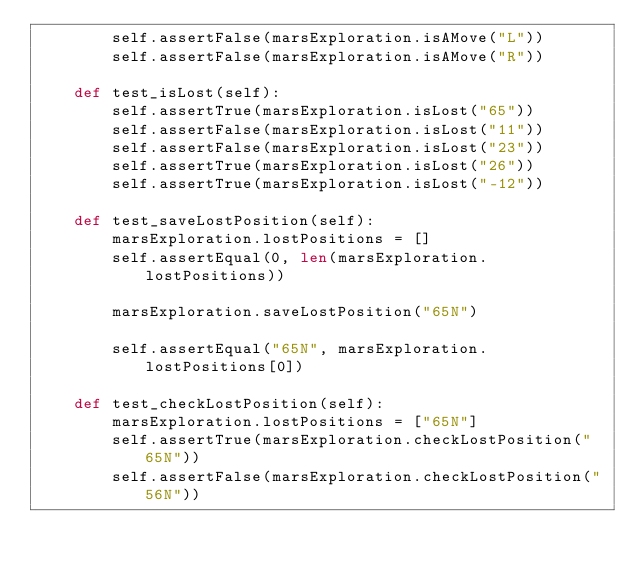Convert code to text. <code><loc_0><loc_0><loc_500><loc_500><_Python_>        self.assertFalse(marsExploration.isAMove("L"))
        self.assertFalse(marsExploration.isAMove("R"))

    def test_isLost(self):
        self.assertTrue(marsExploration.isLost("65"))
        self.assertFalse(marsExploration.isLost("11"))
        self.assertFalse(marsExploration.isLost("23"))
        self.assertTrue(marsExploration.isLost("26"))
        self.assertTrue(marsExploration.isLost("-12"))

    def test_saveLostPosition(self):
        marsExploration.lostPositions = []
        self.assertEqual(0, len(marsExploration.lostPositions))

        marsExploration.saveLostPosition("65N")

        self.assertEqual("65N", marsExploration.lostPositions[0])

    def test_checkLostPosition(self):
        marsExploration.lostPositions = ["65N"]
        self.assertTrue(marsExploration.checkLostPosition("65N"))
        self.assertFalse(marsExploration.checkLostPosition("56N"))
</code> 